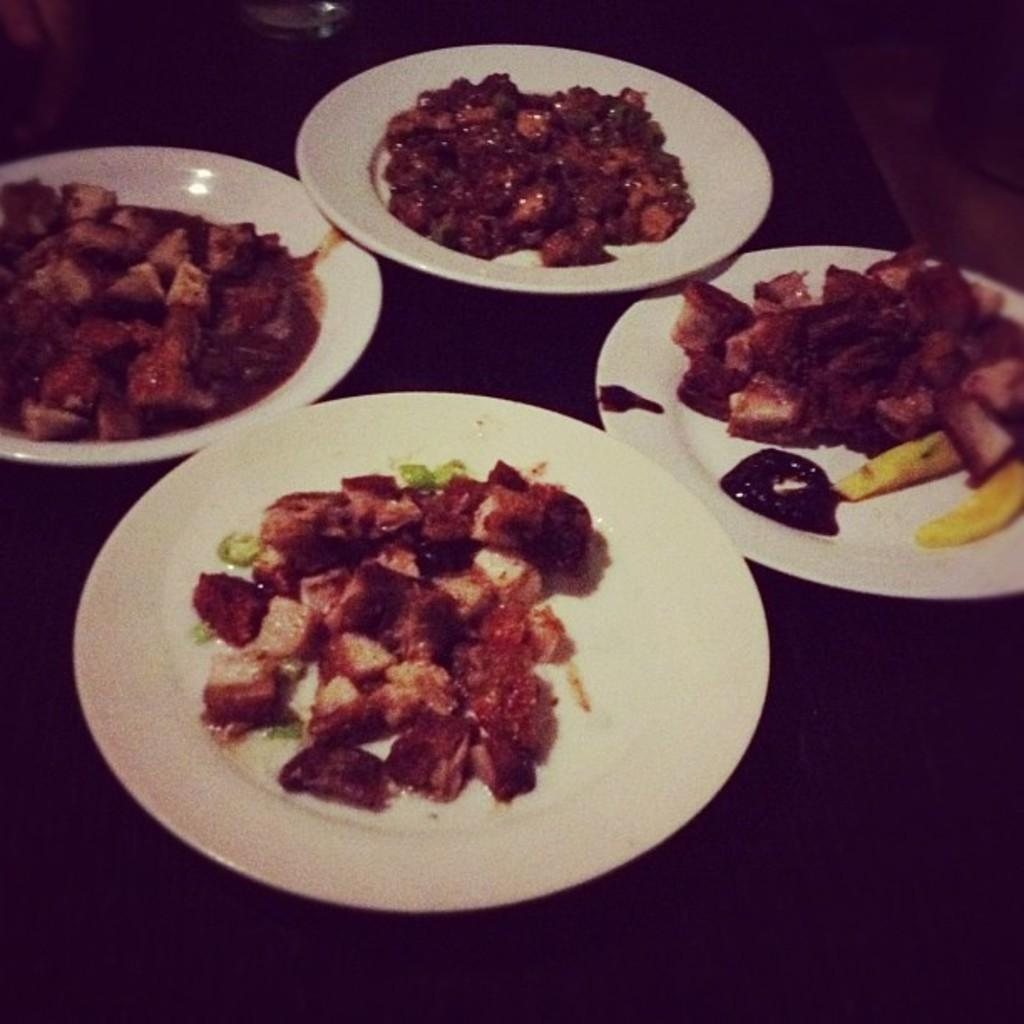How many coughs can be heard coming from the van in the image? There is no van or coughing sounds present in the image. 